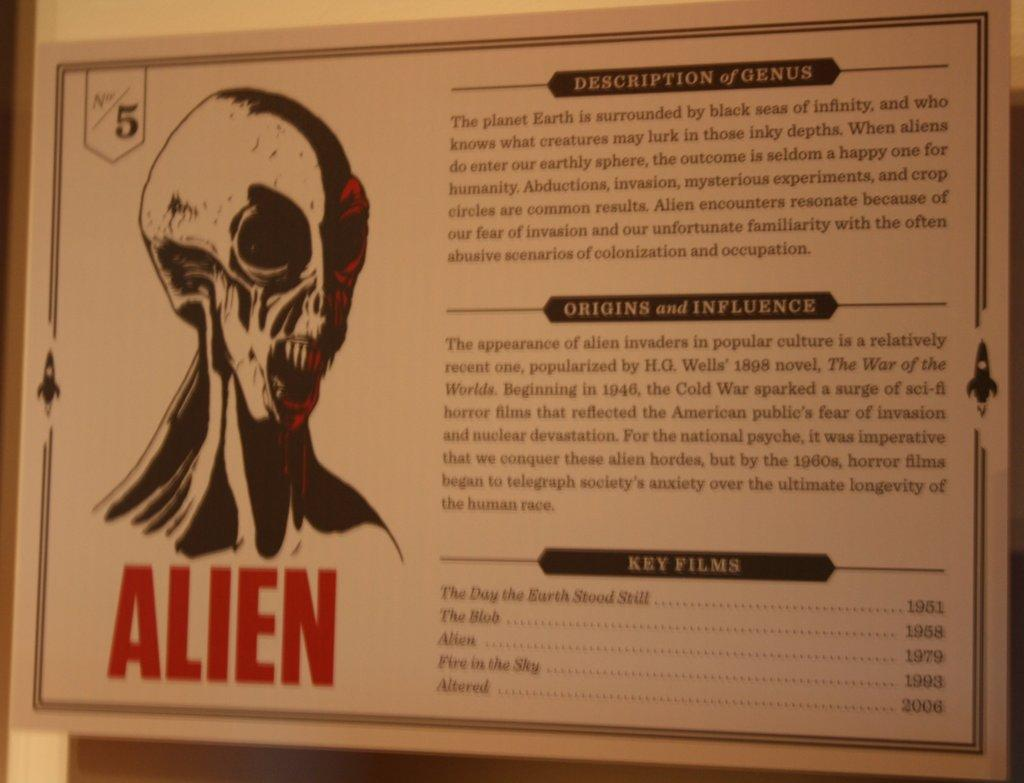What is hanging on the wall in the image? There is a board hanged on a wall in the image. What is depicted on the board? There is a picture of an alien on the board. What type of lawyer is the monkey representing in the image? There is no monkey or lawyer present in the image; it only features a board with a picture of an alien. 